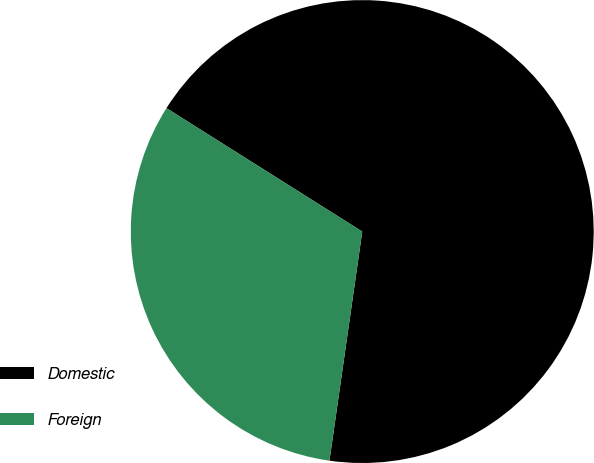<chart> <loc_0><loc_0><loc_500><loc_500><pie_chart><fcel>Domestic<fcel>Foreign<nl><fcel>68.31%<fcel>31.69%<nl></chart> 